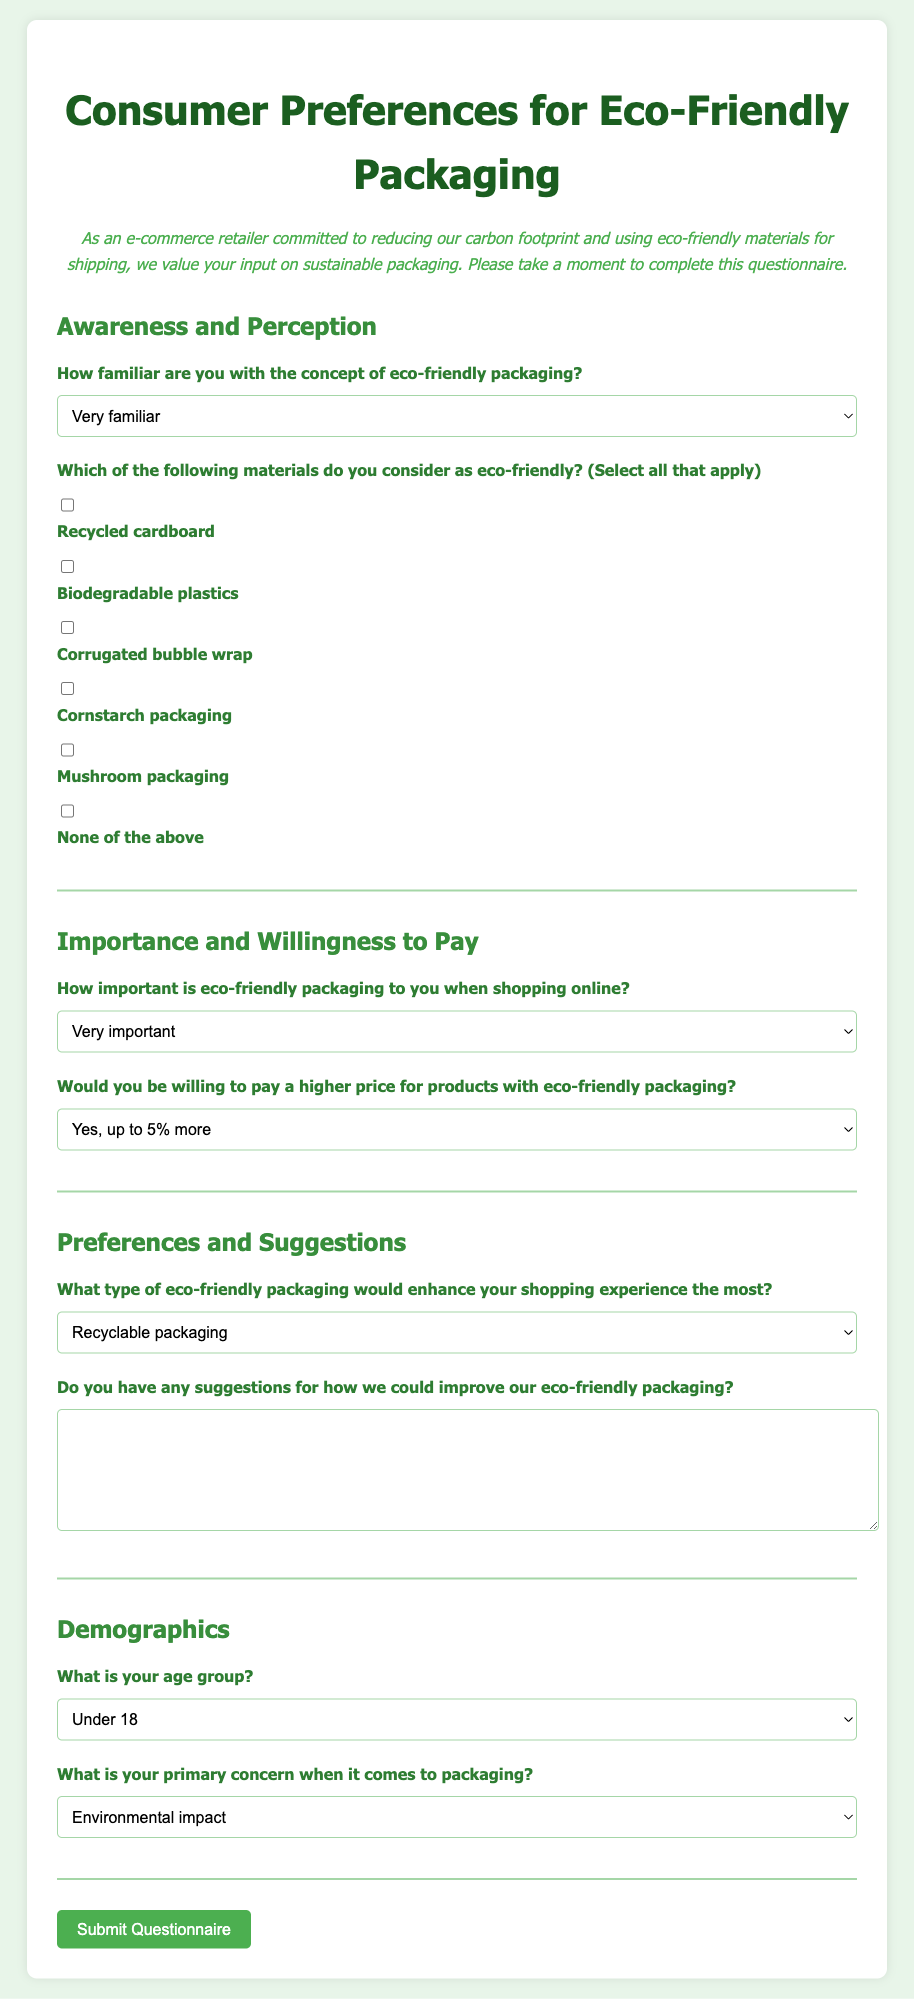How many sections are in the questionnaire? The document contains four main sections: Awareness and Perception, Importance and Willingness to Pay, Preferences and Suggestions, and Demographics.
Answer: 4 What is the title of the questionnaire? The title is prominently displayed at the top of the document, clearly indicating the subject matter of the questionnaire.
Answer: Consumer Preferences for Eco-Friendly Packaging What options are provided for the question about familiarity with eco-friendly packaging? The document lists five options for respondents to select their familiarity level with eco-friendly packaging.
Answer: Very familiar, Somewhat familiar, Neutral, Somewhat unfamiliar, Very unfamiliar What type of packaging does the consumer prefer for enhancing their shopping experience? The question provides multiple-choice options for respondents to express their preferred type of eco-friendly packaging.
Answer: Recyclable packaging, Reusable packaging, Biodegradable packaging, Minimal packaging, Other How important is eco-friendly packaging to consumers when shopping online? Respondents can select from five levels of importance regarding eco-friendly packaging, showcasing their views on its relevance.
Answer: Very important, Important, Neutral, Not very important, Not important at all What is the final question in the Demographics section? The last question in the Demographics section asks respondents about their primary concern when it comes to packaging.
Answer: What is your primary concern when it comes to packaging? Would consumers be willing to pay more for eco-friendly packaging? The document includes a question that gauges consumers' willingness to pay a higher price for eco-friendly packaging, with options provided.
Answer: Yes, up to 5% more; Yes, up to 10% more; Yes, up to 15% more; No, I prefer standard packaging at a lower cost What is the background color of the document? The background color of the body of the document is specified in the styling and contributes to the visual aesthetics.
Answer: Light green (e8f5e9) 